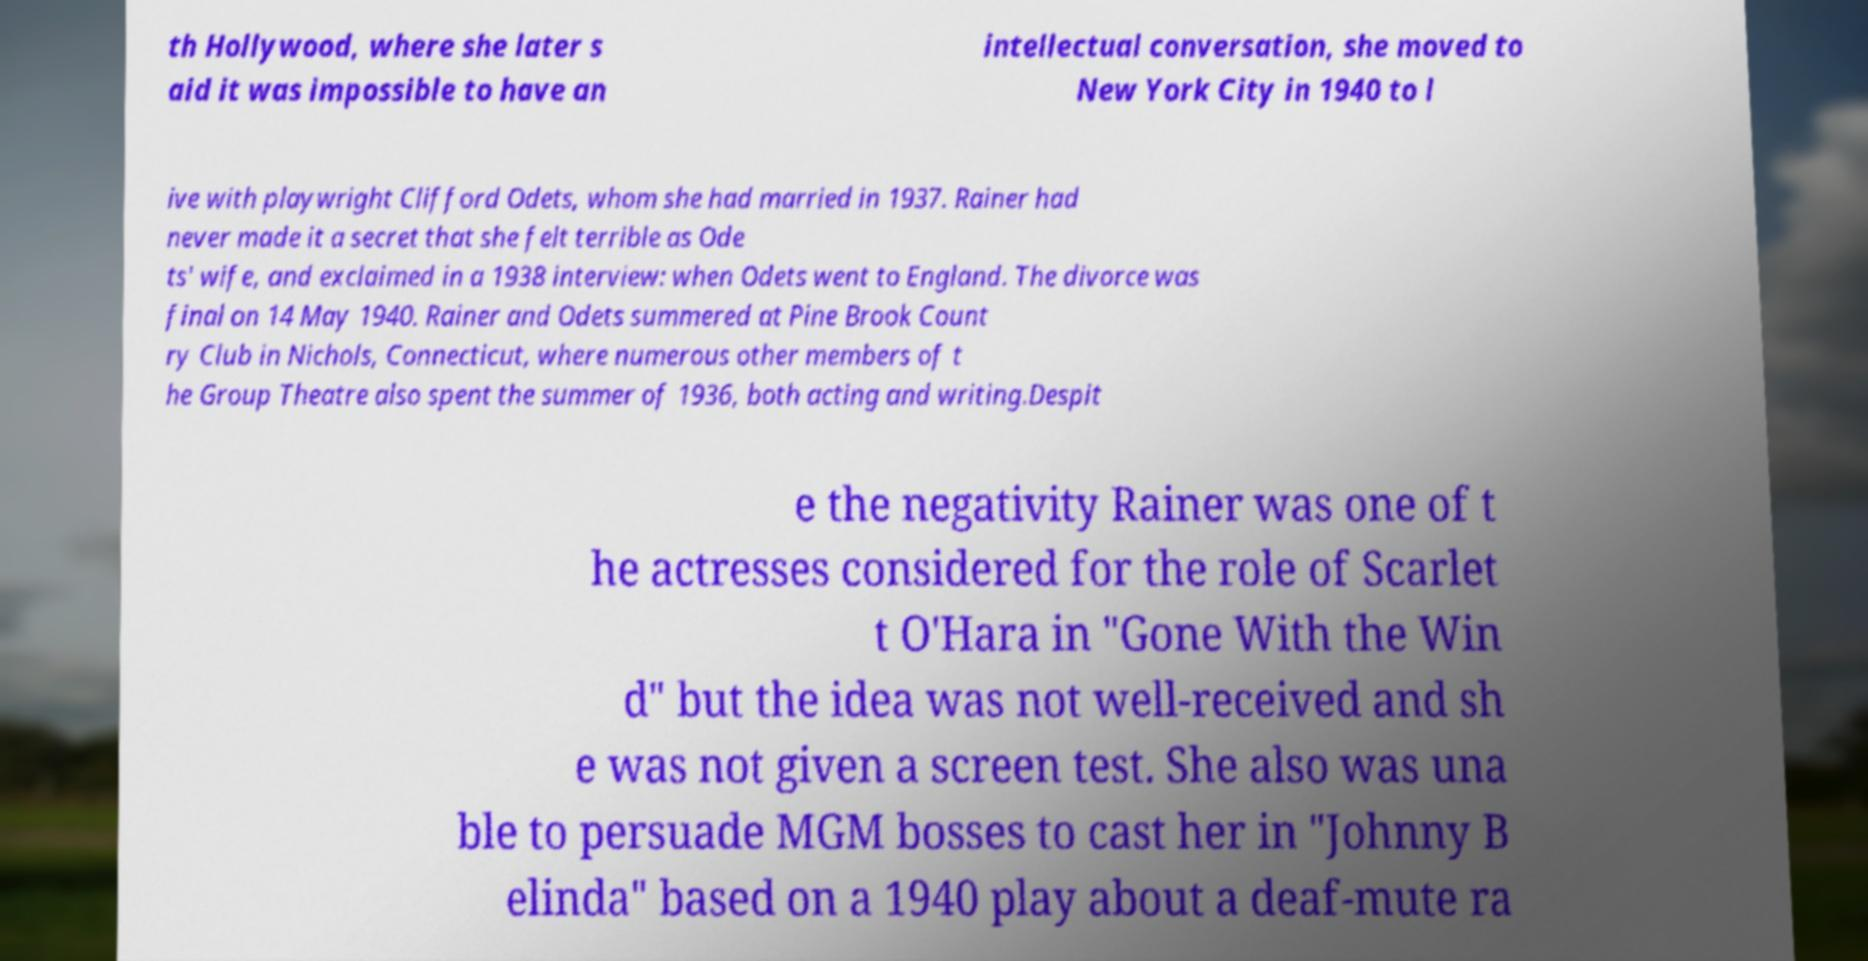Please identify and transcribe the text found in this image. th Hollywood, where she later s aid it was impossible to have an intellectual conversation, she moved to New York City in 1940 to l ive with playwright Clifford Odets, whom she had married in 1937. Rainer had never made it a secret that she felt terrible as Ode ts' wife, and exclaimed in a 1938 interview: when Odets went to England. The divorce was final on 14 May 1940. Rainer and Odets summered at Pine Brook Count ry Club in Nichols, Connecticut, where numerous other members of t he Group Theatre also spent the summer of 1936, both acting and writing.Despit e the negativity Rainer was one of t he actresses considered for the role of Scarlet t O'Hara in "Gone With the Win d" but the idea was not well-received and sh e was not given a screen test. She also was una ble to persuade MGM bosses to cast her in "Johnny B elinda" based on a 1940 play about a deaf-mute ra 